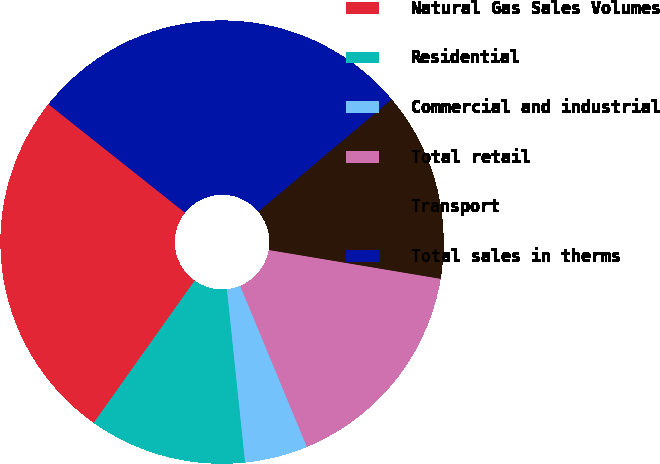Convert chart. <chart><loc_0><loc_0><loc_500><loc_500><pie_chart><fcel>Natural Gas Sales Volumes<fcel>Residential<fcel>Commercial and industrial<fcel>Total retail<fcel>Transport<fcel>Total sales in therms<nl><fcel>25.86%<fcel>11.48%<fcel>4.59%<fcel>16.1%<fcel>13.79%<fcel>28.17%<nl></chart> 